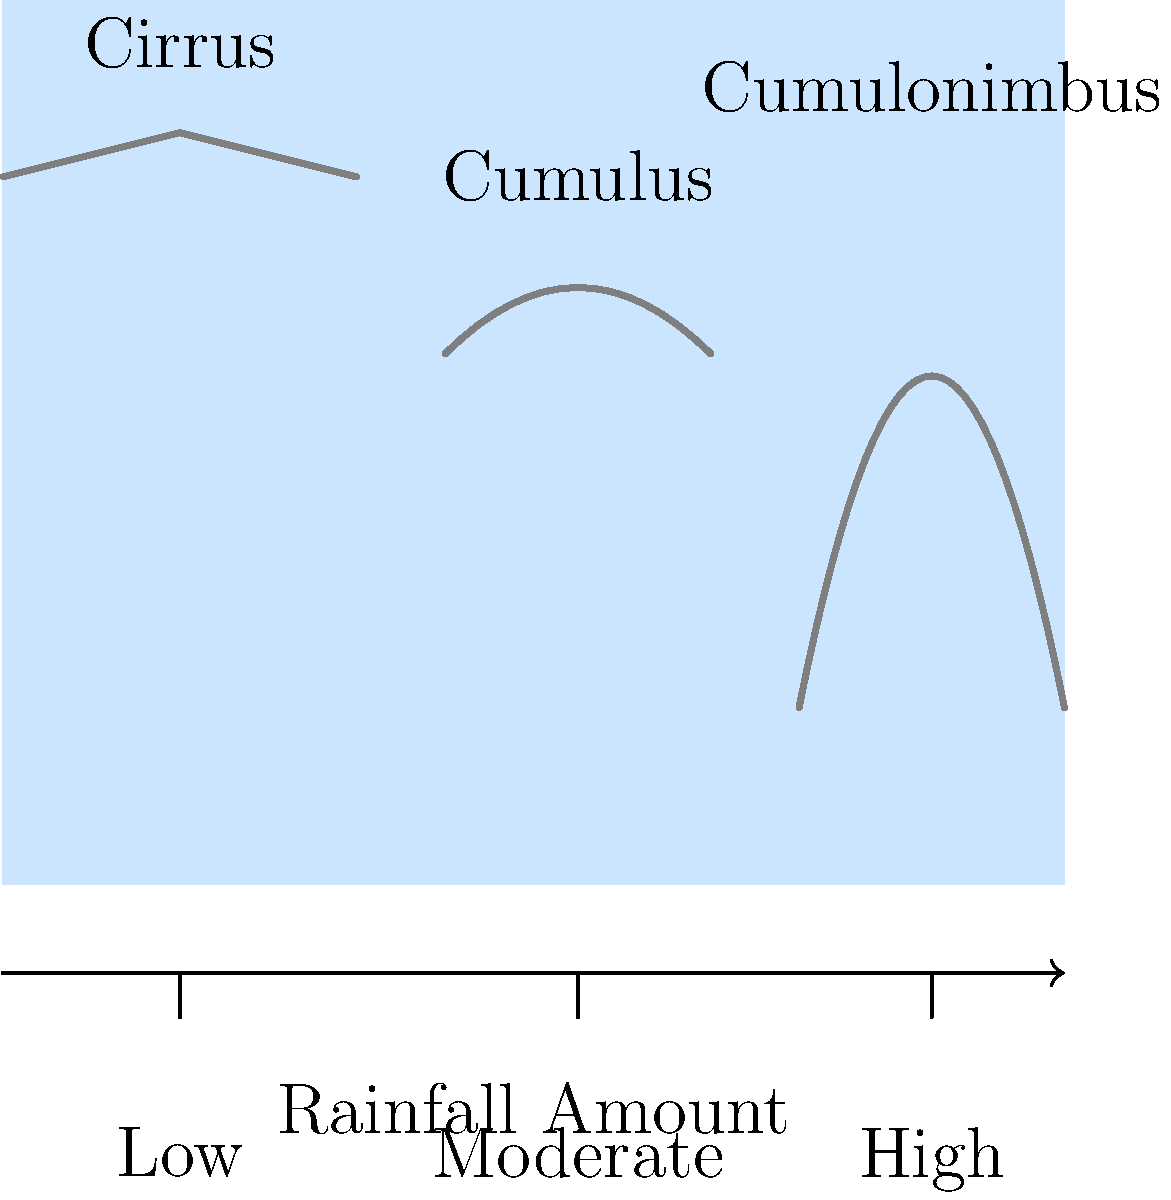Based on the cloud patterns shown in the satellite image, which type of cloud is most likely to produce the highest amount of rainfall? Let's analyze the cloud types shown in the image:

1. Cirrus clouds: These are thin, wispy clouds found at high altitudes. They are composed of ice crystals and typically do not produce precipitation.

2. Cumulus clouds: These are fluffy, white clouds with flat bases. They can sometimes develop into rain clouds, but generally produce light to moderate rainfall.

3. Cumulonimbus clouds: These are tall, dense clouds that extend vertically from low to high altitudes. They are associated with thunderstorms and heavy precipitation.

To determine which cloud type produces the highest amount of rainfall:

1. Cirrus clouds produce no rainfall, so they can be eliminated.
2. Cumulus clouds can produce some rainfall, but it's usually light to moderate.
3. Cumulonimbus clouds are known for producing heavy rainfall, thunderstorms, and even hail.

Therefore, based on the cloud patterns shown in the satellite image, cumulonimbus clouds are most likely to produce the highest amount of rainfall.
Answer: Cumulonimbus clouds 